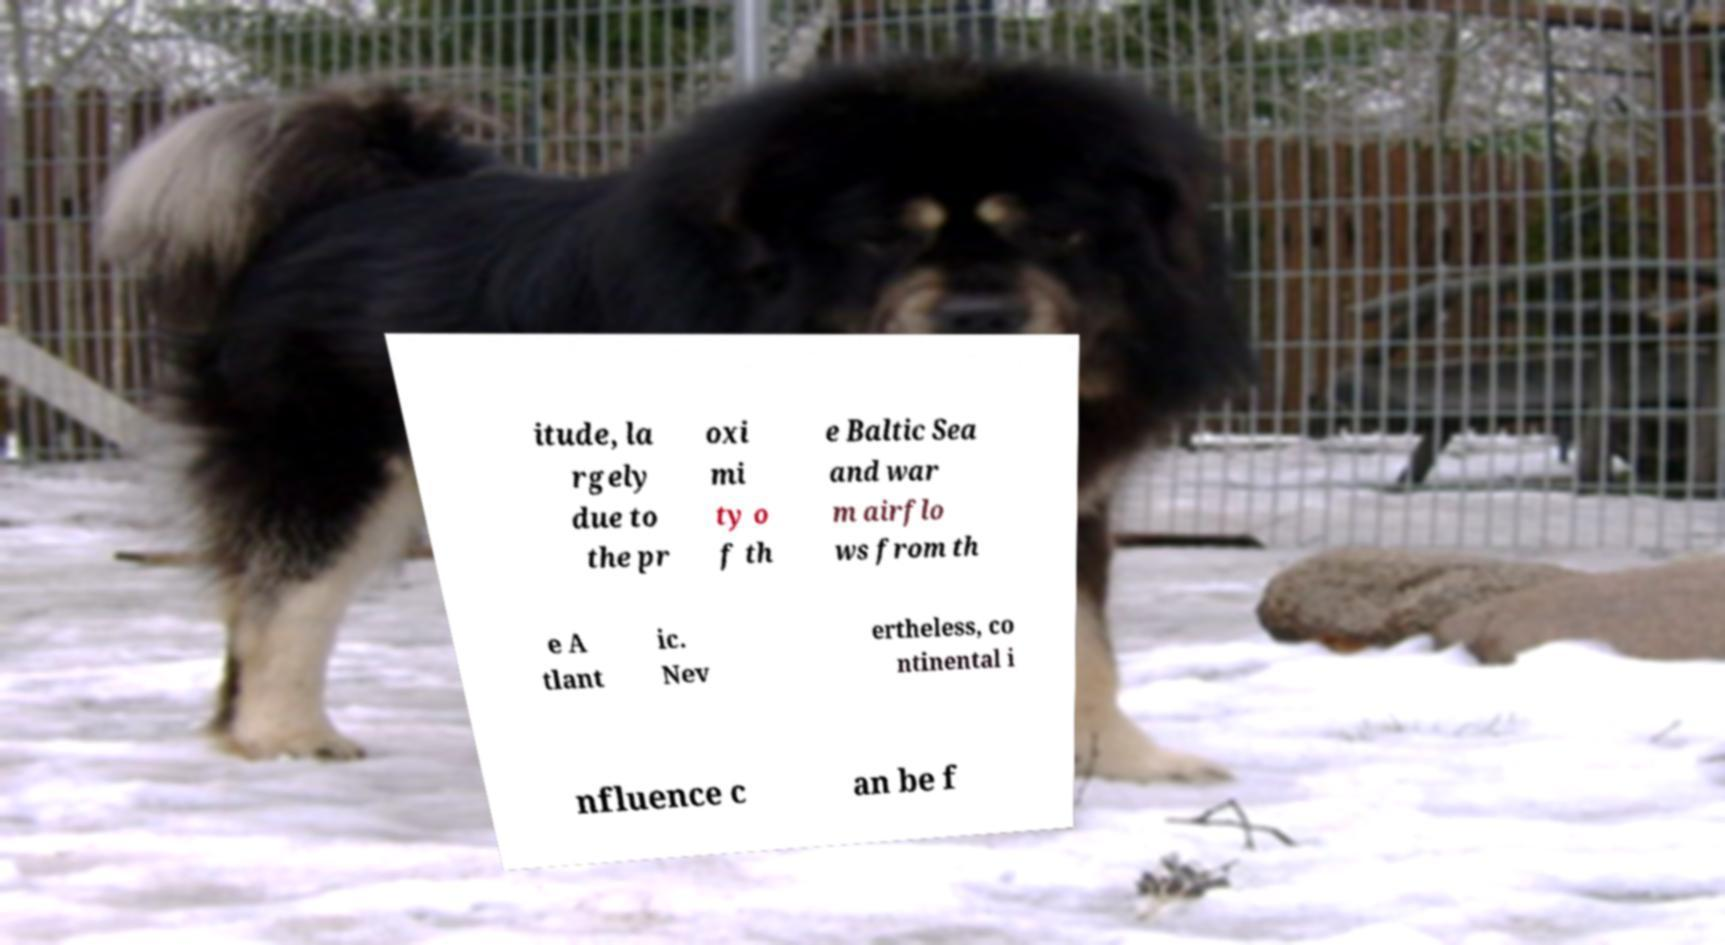Can you read and provide the text displayed in the image?This photo seems to have some interesting text. Can you extract and type it out for me? itude, la rgely due to the pr oxi mi ty o f th e Baltic Sea and war m airflo ws from th e A tlant ic. Nev ertheless, co ntinental i nfluence c an be f 